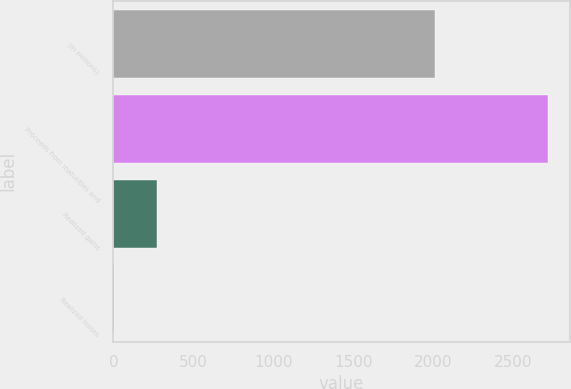Convert chart. <chart><loc_0><loc_0><loc_500><loc_500><bar_chart><fcel>(In millions)<fcel>Proceeds from maturities and<fcel>Realized gains<fcel>Realized losses<nl><fcel>2014<fcel>2718.9<fcel>272.34<fcel>0.5<nl></chart> 